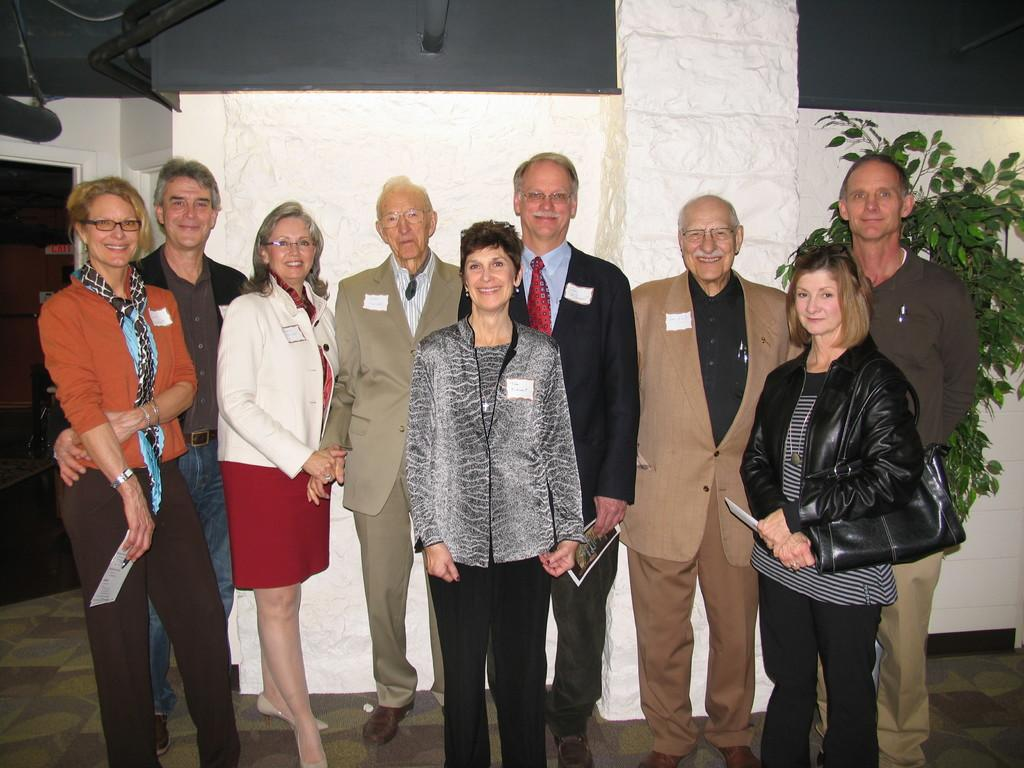How many people can be seen in the image? There are many people standing in the image. What are some people holding in their hands? Some people are holding something in their hands, but the specific items are not mentioned in the facts. What is the lady holding in the image? The lady is holding a bag. What can be seen in the background of the image? There is a plant and a wall in the background of the image. What type of chairs are visible in the image? There are no chairs present in the image. What kind of apparel is the lady wearing in the image? The facts do not mention the lady's apparel, so we cannot determine what she is wearing. 